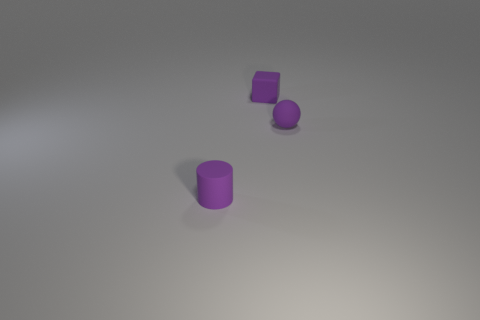What material is the tiny object in front of the small purple object right of the small purple thing that is behind the tiny rubber ball made of?
Provide a short and direct response. Rubber. What size is the purple ball that is the same material as the purple cylinder?
Make the answer very short. Small. Are there any other things that have the same color as the small sphere?
Offer a terse response. Yes. There is a thing behind the matte sphere; is it the same color as the small rubber object that is in front of the tiny sphere?
Your answer should be very brief. Yes. The tiny rubber object that is to the right of the block is what color?
Make the answer very short. Purple. There is a thing behind the matte ball; does it have the same size as the tiny ball?
Your answer should be very brief. Yes. Is the number of large red metallic blocks less than the number of matte blocks?
Provide a short and direct response. Yes. What number of tiny objects are right of the small cylinder?
Give a very brief answer. 2. What number of objects are both in front of the matte ball and behind the purple ball?
Offer a terse response. 0. What number of things are either cubes or matte things in front of the purple matte cube?
Keep it short and to the point. 3. 